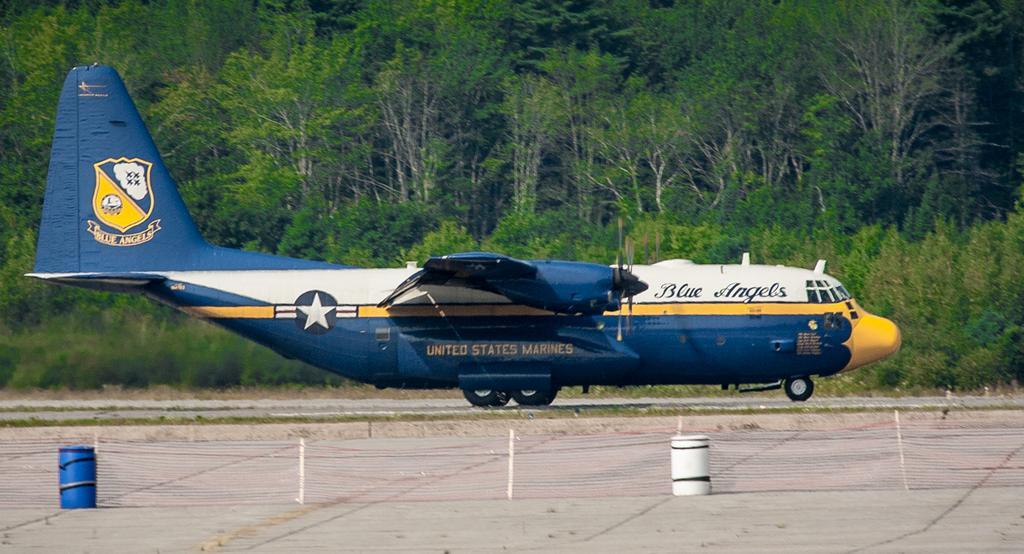Could you give a brief overview of what you see in this image? In this image there is an airplane on the ground. There are text and logo on the airplane. Behind the airplane there are trees and plants on the ground. In the foreground there are barrels on the ground. 